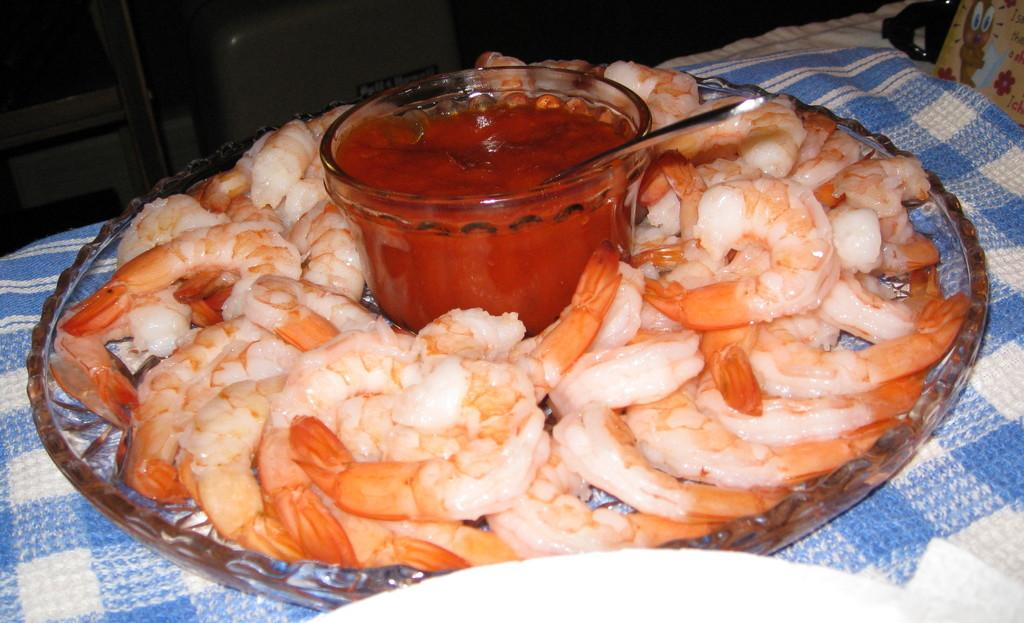What type of food can be seen in the image? There are prawns in the image. What is the prawns served with? There is a bowl with sauce in the image. What utensil is present in the image? There is a spoon in the image. What is the prawns served on? There is a plate in the image. What is the plate placed on? The plate is placed on a cloth. How many bikes are parked next to the plate in the image? There are no bikes present in the image. What type of reward is given to the prawns in the image? The prawns are not given any reward in the image; they are simply served on a plate with sauce. 